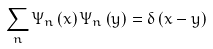Convert formula to latex. <formula><loc_0><loc_0><loc_500><loc_500>\sum _ { n } \Psi _ { n } \left ( x \right ) \Psi _ { n } \left ( y \right ) = \delta \left ( x - y \right )</formula> 